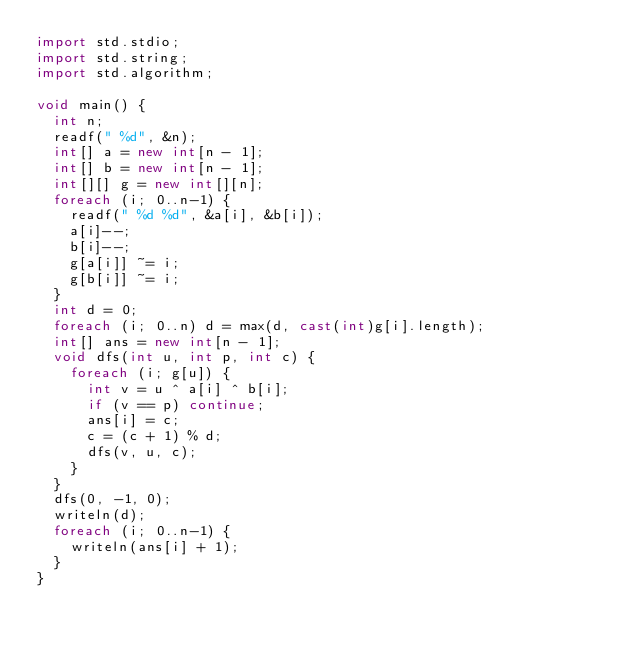<code> <loc_0><loc_0><loc_500><loc_500><_D_>import std.stdio;
import std.string;
import std.algorithm;

void main() {
  int n;
  readf(" %d", &n);
  int[] a = new int[n - 1];
  int[] b = new int[n - 1];
  int[][] g = new int[][n];
  foreach (i; 0..n-1) {
    readf(" %d %d", &a[i], &b[i]);
    a[i]--;
    b[i]--;
    g[a[i]] ~= i;
    g[b[i]] ~= i;
  }
  int d = 0;
  foreach (i; 0..n) d = max(d, cast(int)g[i].length);
  int[] ans = new int[n - 1];
  void dfs(int u, int p, int c) {
    foreach (i; g[u]) {
      int v = u ^ a[i] ^ b[i];
      if (v == p) continue;
      ans[i] = c;
      c = (c + 1) % d;
      dfs(v, u, c);
    }
  }
  dfs(0, -1, 0);
  writeln(d);
  foreach (i; 0..n-1) {
    writeln(ans[i] + 1);
  }
}
</code> 